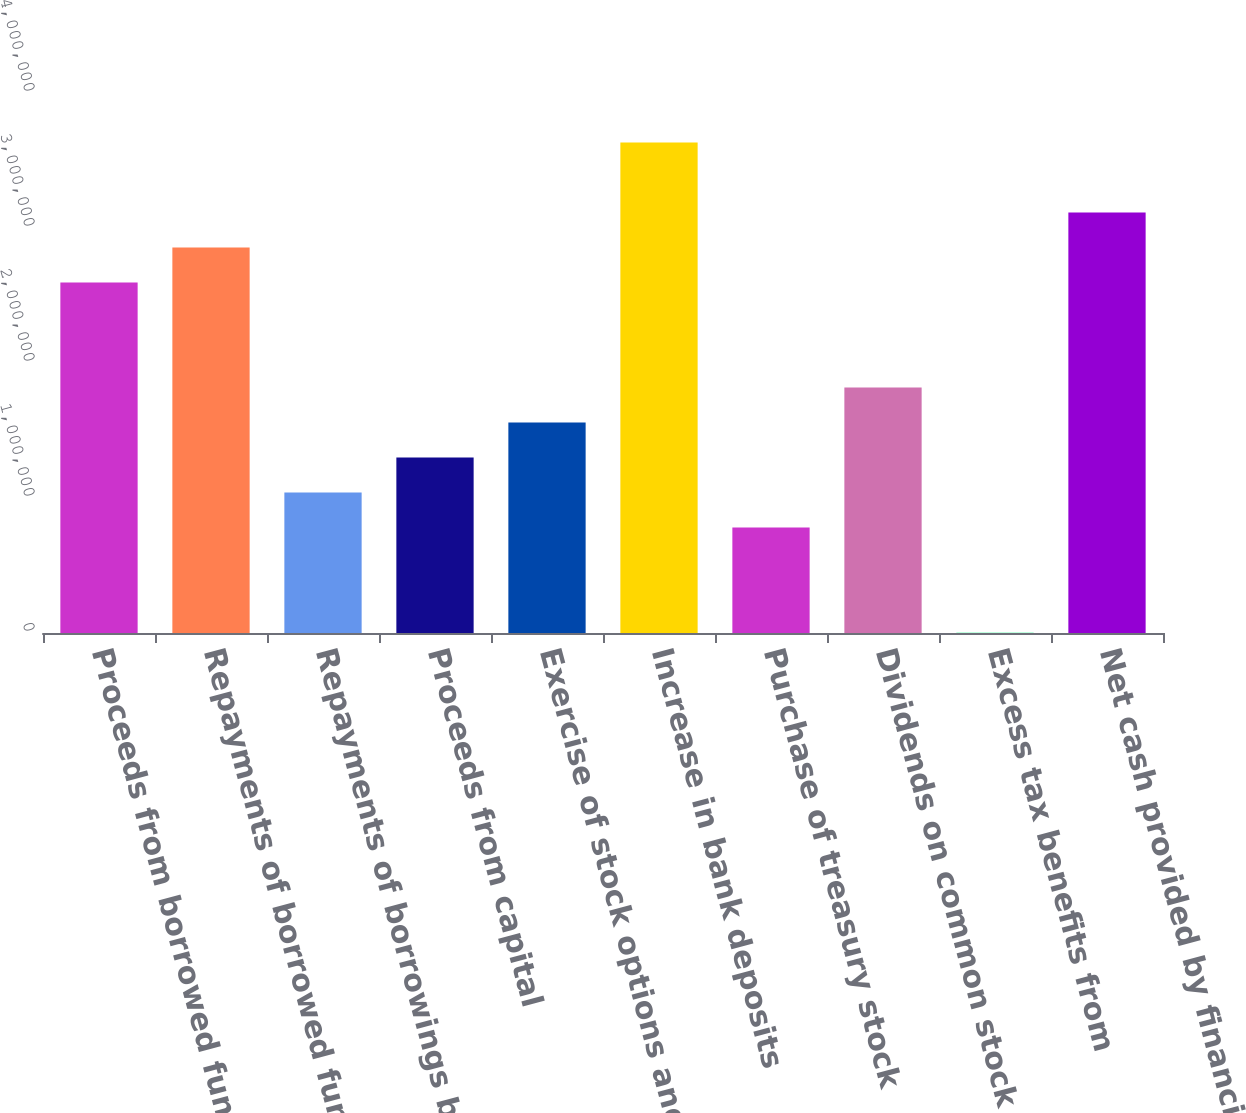<chart> <loc_0><loc_0><loc_500><loc_500><bar_chart><fcel>Proceeds from borrowed funds<fcel>Repayments of borrowed funds<fcel>Repayments of borrowings by<fcel>Proceeds from capital<fcel>Exercise of stock options and<fcel>Increase in bank deposits<fcel>Purchase of treasury stock<fcel>Dividends on common stock<fcel>Excess tax benefits from<fcel>Net cash provided by financing<nl><fcel>2.59662e+06<fcel>2.85602e+06<fcel>1.0402e+06<fcel>1.2996e+06<fcel>1.55901e+06<fcel>3.63423e+06<fcel>780798<fcel>1.81841e+06<fcel>2590<fcel>3.11542e+06<nl></chart> 